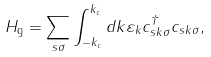Convert formula to latex. <formula><loc_0><loc_0><loc_500><loc_500>H _ { \text {g} } = \sum _ { s \sigma } \int ^ { k _ { c } } _ { - k _ { c } } d k \varepsilon _ { k } c ^ { \dagger } _ { s k \sigma } c _ { s k \sigma } ,</formula> 